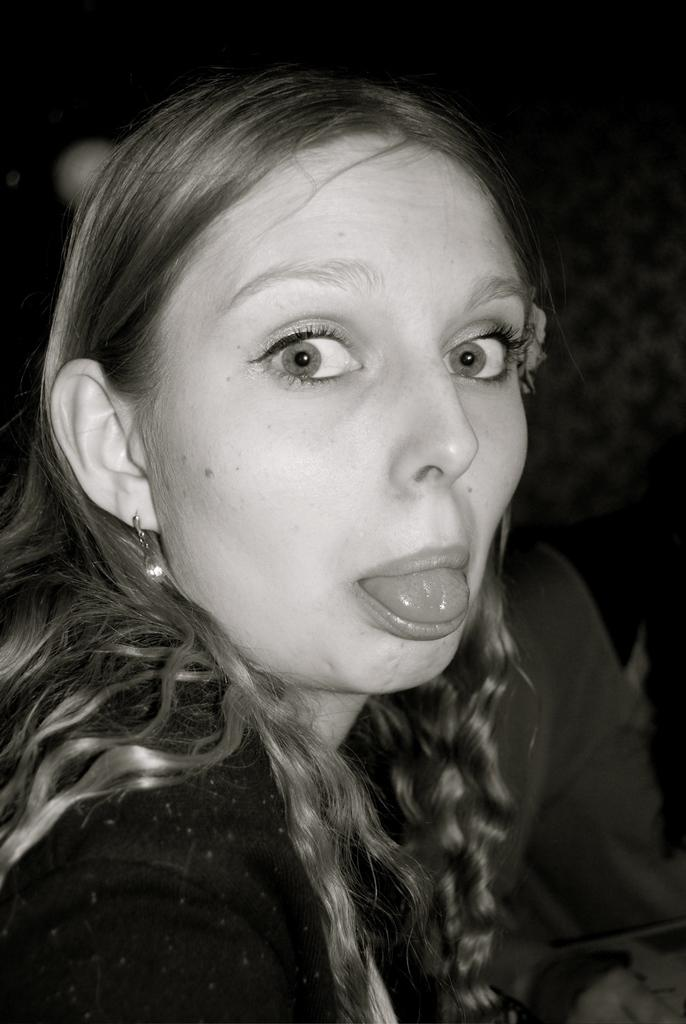What is the color scheme of the image? The image is black and white. Can you describe the main subject of the image? There is a woman in the image. How many eggs are present in the image? There are no eggs present in the image; it only features a woman. Is the woman in the image sinking into quicksand? There is no quicksand present in the image, and the woman is not sinking into anything. 